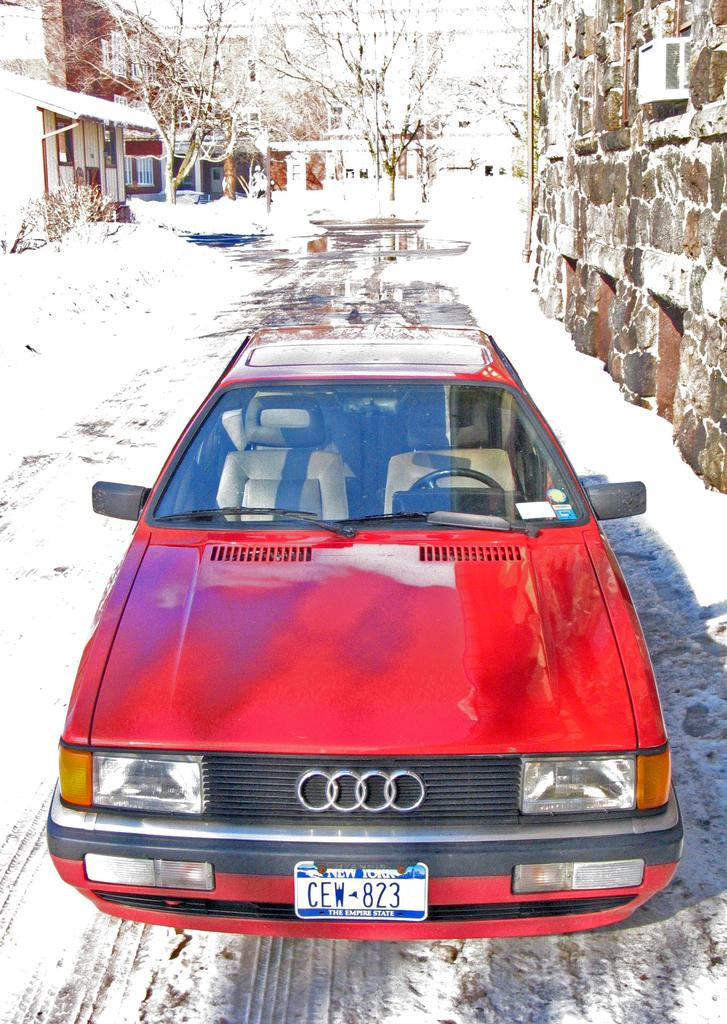What is the main subject in the center of the image? There is a red car in the center of the image. What can be seen in the background of the image? There are buildings and trees in the background of the image. What is the weather like in the image? Snow is visible in the image, indicating a cold or wintery environment. What is located on the right side of the image? There is a wall on the right side of the image. What type of coal can be seen in the image? There is no coal present in the image. How many levels are visible in the buildings in the image? The image does not provide enough detail to determine the number of levels in the buildings. 